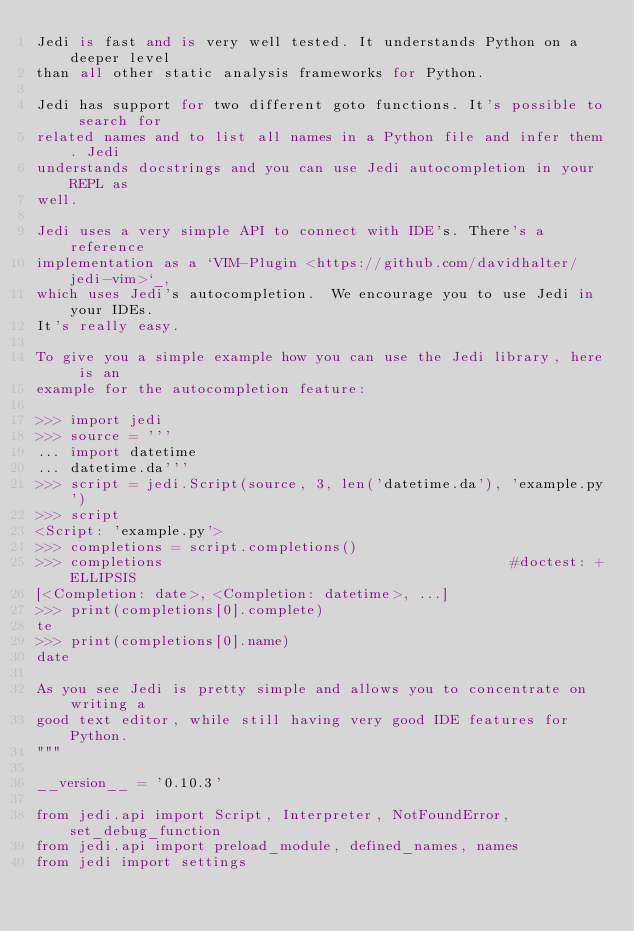Convert code to text. <code><loc_0><loc_0><loc_500><loc_500><_Python_>Jedi is fast and is very well tested. It understands Python on a deeper level
than all other static analysis frameworks for Python.

Jedi has support for two different goto functions. It's possible to search for
related names and to list all names in a Python file and infer them. Jedi
understands docstrings and you can use Jedi autocompletion in your REPL as
well.

Jedi uses a very simple API to connect with IDE's. There's a reference
implementation as a `VIM-Plugin <https://github.com/davidhalter/jedi-vim>`_,
which uses Jedi's autocompletion.  We encourage you to use Jedi in your IDEs.
It's really easy.

To give you a simple example how you can use the Jedi library, here is an
example for the autocompletion feature:

>>> import jedi
>>> source = '''
... import datetime
... datetime.da'''
>>> script = jedi.Script(source, 3, len('datetime.da'), 'example.py')
>>> script
<Script: 'example.py'>
>>> completions = script.completions()
>>> completions                                         #doctest: +ELLIPSIS
[<Completion: date>, <Completion: datetime>, ...]
>>> print(completions[0].complete)
te
>>> print(completions[0].name)
date

As you see Jedi is pretty simple and allows you to concentrate on writing a
good text editor, while still having very good IDE features for Python.
"""

__version__ = '0.10.3'

from jedi.api import Script, Interpreter, NotFoundError, set_debug_function
from jedi.api import preload_module, defined_names, names
from jedi import settings
</code> 